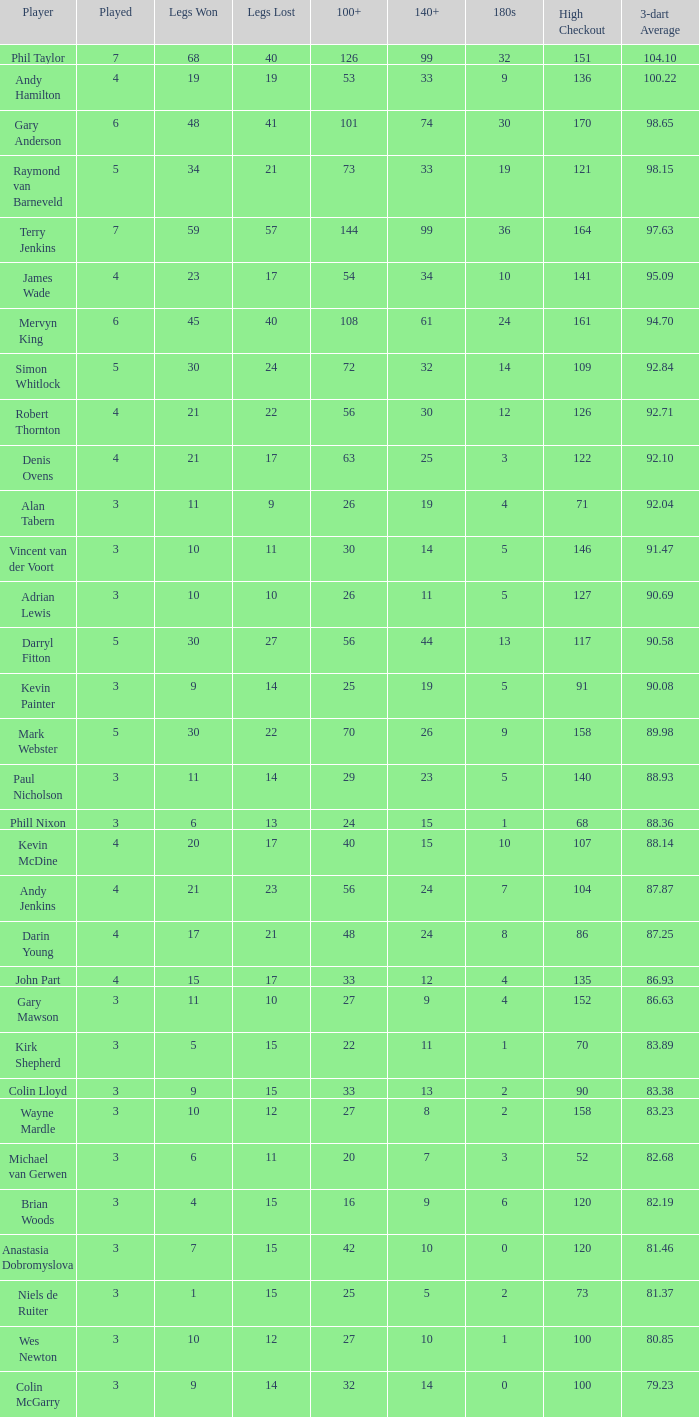What is the highest Legs Lost with a 180s larger than 1, a 100+ of 53, and played is smaller than 4? None. 